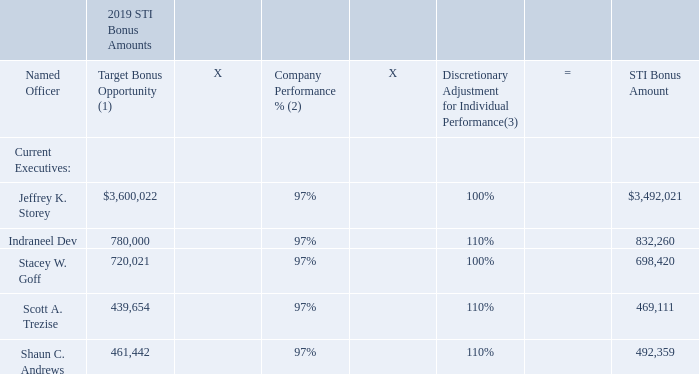Actual STI Bonus Amounts Authorized. The actual amounts of the NEOs’ 2019 bonuses were calculated as
follows:
(1) Determined based on earned salary and applicable STI target bonus percentage during 2019 and includes pro-rations for any changes to salary and/or STI target bonus percentage described below.
a) Target Bonus Opportunity for Mr. Storey reflects his salary earned during 2019 of $1,800,011 and a STI target bonus percentage of 200%.
b) Target Bonus Opportunity for Mr. Dev reflects his salary earned during 2019 of $650,000 and a STI target bonus percentage of 120%.
c) Target Bonus Opportunity for Mr. Goff reflects his salary earned during 2019 of $600,018 and a STI target bonus percentage of 120%.
d) Target Bonus Opportunity for Mr. Trezise reflects his salary earned during 2019 with a salary increase, from $475,010 to $500,011, effective on February 23, 2019, and an increase of STI target bonus percentage from 80% to 90%, also effective on February 23, 2019.
e) Target Bonus Opportunity for Mr. Andrews reflects his salary earned during 2019 with a salary increase, from $425,006 to $525,000, effective on August 21, 2019, and a STI target bonus percentage of 100%.
(2) Calculated or determined as discussed above under “—2019 Performance Results.”
(3) Determined based on achievement of individual performance objectives as described further above in this Subsection.
Committee Discretion to Pay in Cash or Shares. The Committee may authorize the payment of annual bonuses in cash or shares of common stock. Since 2000, the Committee has paid these bonuses entirely in cash, principally to diversify our compensation mix and to conserve shares in our equity plans.
Recent Actions (February 2020). In connection with establishing targets for the 2020 STI program, the Committee increased Mr. Dev’s STI Target Bonus Percentage to 125%, in light of his position to market and performance as CFO, and made no changes to the target bonus percentage for any of our other NEOs.
How is the discretionary adjustment for individual performance determined? Based on achievement of individual performance objectives. What is Jeffrey K. Storey's salary earned during 2019? $1,800,011. Which current executives have a STI target bonus percentage of 120%? Indraneel dev, stacey w. goff. How many current executives have a STI bonus amount greater than $500,000? Jeffrey K. Storey##Indraneel Dev##Stacey W. Goff
Answer: 3. What is Indraneel Dev's salary earned during 2019 expressed as a ratio of his/her STI bonus amount?
Answer scale should be: percent. $650,000/$832,260
Answer: 78.1. What is the percentage change of Scott A. Trezise's salary increase?
Answer scale should be: percent. ($500,011-$475,010)/$475,010
Answer: 5.26. 